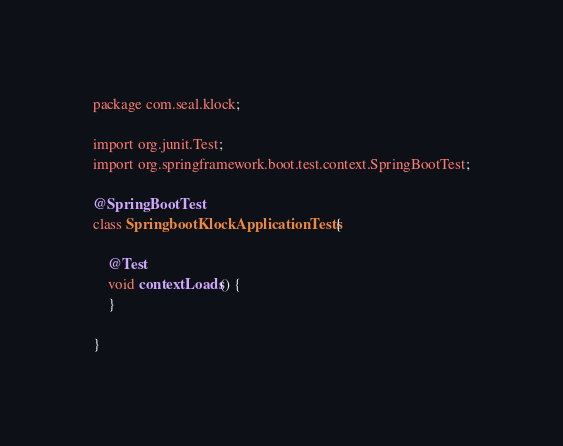<code> <loc_0><loc_0><loc_500><loc_500><_Java_>package com.seal.klock;

import org.junit.Test;
import org.springframework.boot.test.context.SpringBootTest;

@SpringBootTest
class SpringbootKlockApplicationTests {

    @Test
    void contextLoads() {
    }

}
</code> 